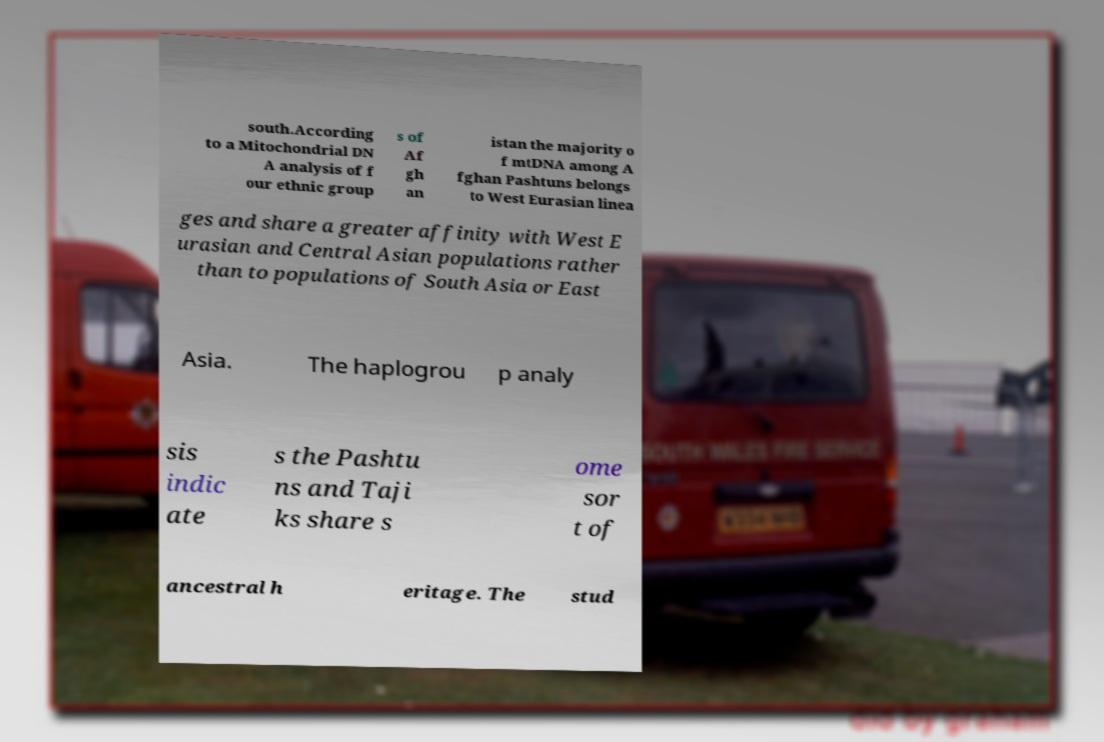Can you accurately transcribe the text from the provided image for me? south.According to a Mitochondrial DN A analysis of f our ethnic group s of Af gh an istan the majority o f mtDNA among A fghan Pashtuns belongs to West Eurasian linea ges and share a greater affinity with West E urasian and Central Asian populations rather than to populations of South Asia or East Asia. The haplogrou p analy sis indic ate s the Pashtu ns and Taji ks share s ome sor t of ancestral h eritage. The stud 